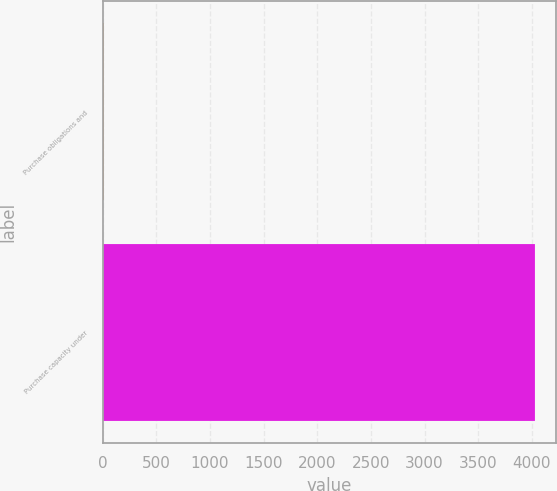Convert chart. <chart><loc_0><loc_0><loc_500><loc_500><bar_chart><fcel>Purchase obligations and<fcel>Purchase capacity under<nl><fcel>17.7<fcel>4028<nl></chart> 